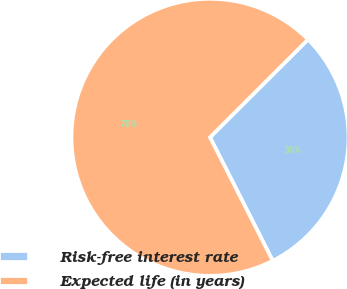Convert chart. <chart><loc_0><loc_0><loc_500><loc_500><pie_chart><fcel>Risk-free interest rate<fcel>Expected life (in years)<nl><fcel>30.0%<fcel>70.0%<nl></chart> 